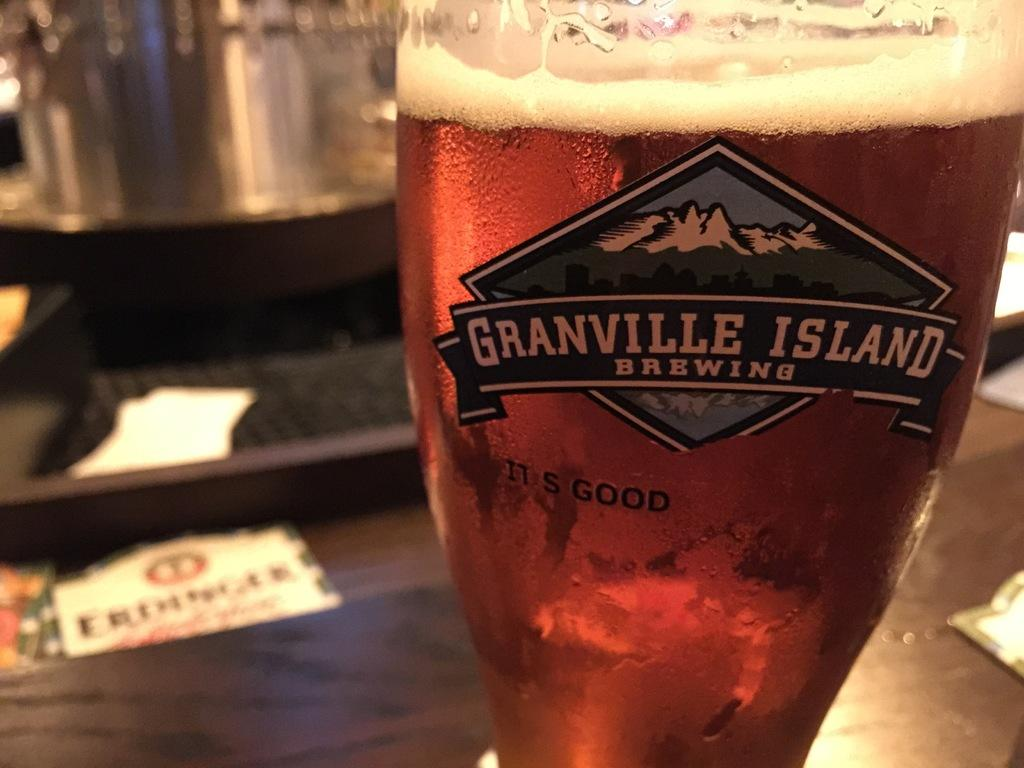<image>
Present a compact description of the photo's key features. A glass that advertises Granville Island Brewing is filled with beer. 